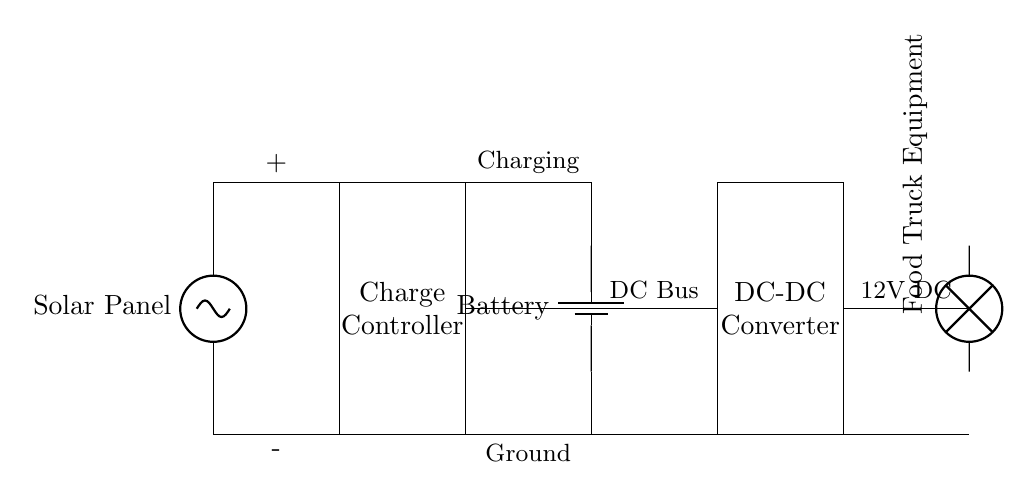What is the main component that generates electricity? The main component that generates electricity in this circuit is the solar panel, which converts sunlight into electrical energy.
Answer: Solar Panel What is the purpose of the charge controller? The charge controller regulates the voltage and current coming from the solar panel to the battery, preventing overcharging and ensuring safe operation.
Answer: Charge Controller What type of converter is used in this circuit? The circuit uses a DC-DC converter, which changes the voltage level to match the requirements of the food truck equipment.
Answer: DC-DC Converter What is the voltage level noted in the circuit? The voltage level noted in the circuit for the load is 12 volts, which is the standard requirement for most food truck equipment.
Answer: 12V How do the solar panel and battery connect in the circuit? The solar panel connects directly to the charge controller, which then connects to the battery, thus forming a path for energy storage.
Answer: Through the charge controller What happens if the battery is fully charged? If the battery is fully charged, the charge controller will prevent further charging from the solar panel, protecting the battery from damage.
Answer: Prevents overcharging What is the role of the load in this circuit? The load in this circuit represents the food truck equipment that uses the electrical energy provided by the battery and DC-DC converter to operate.
Answer: Food Truck Equipment 